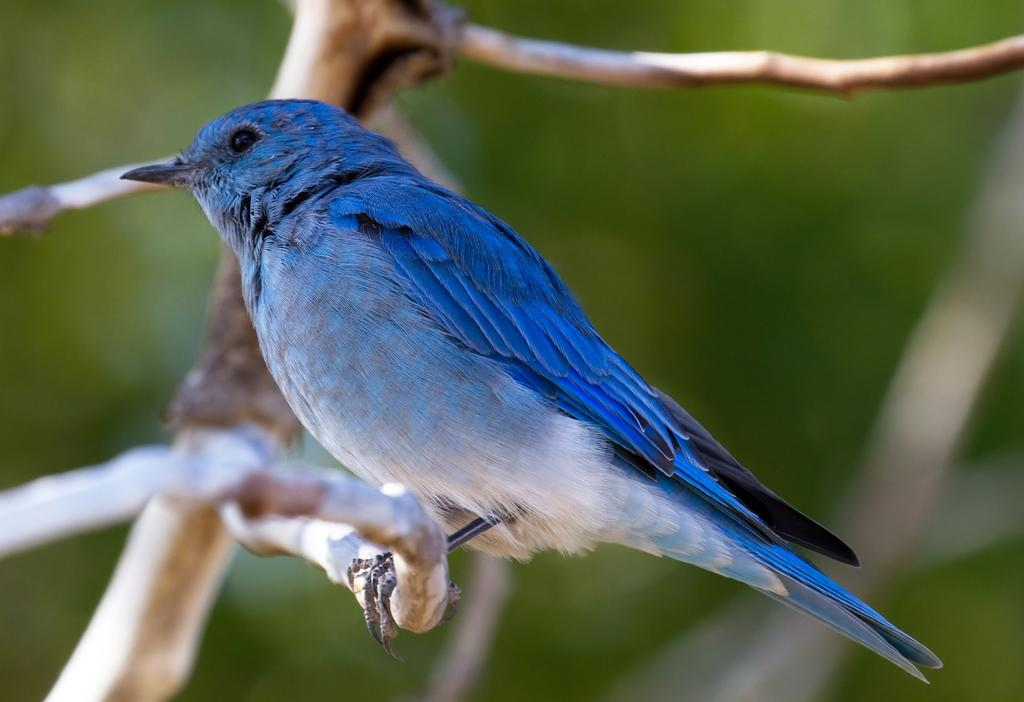What type of bird can be seen in the image? There is a blue color bird in the image. Where is the bird located in the image? The bird is sitting on a tree branch. What can be observed in the background of the image? The background of the image is green and blurred. What type of legal advice is the bird providing in the image? There is no indication in the image that the bird is providing legal advice or is a lawyer. 